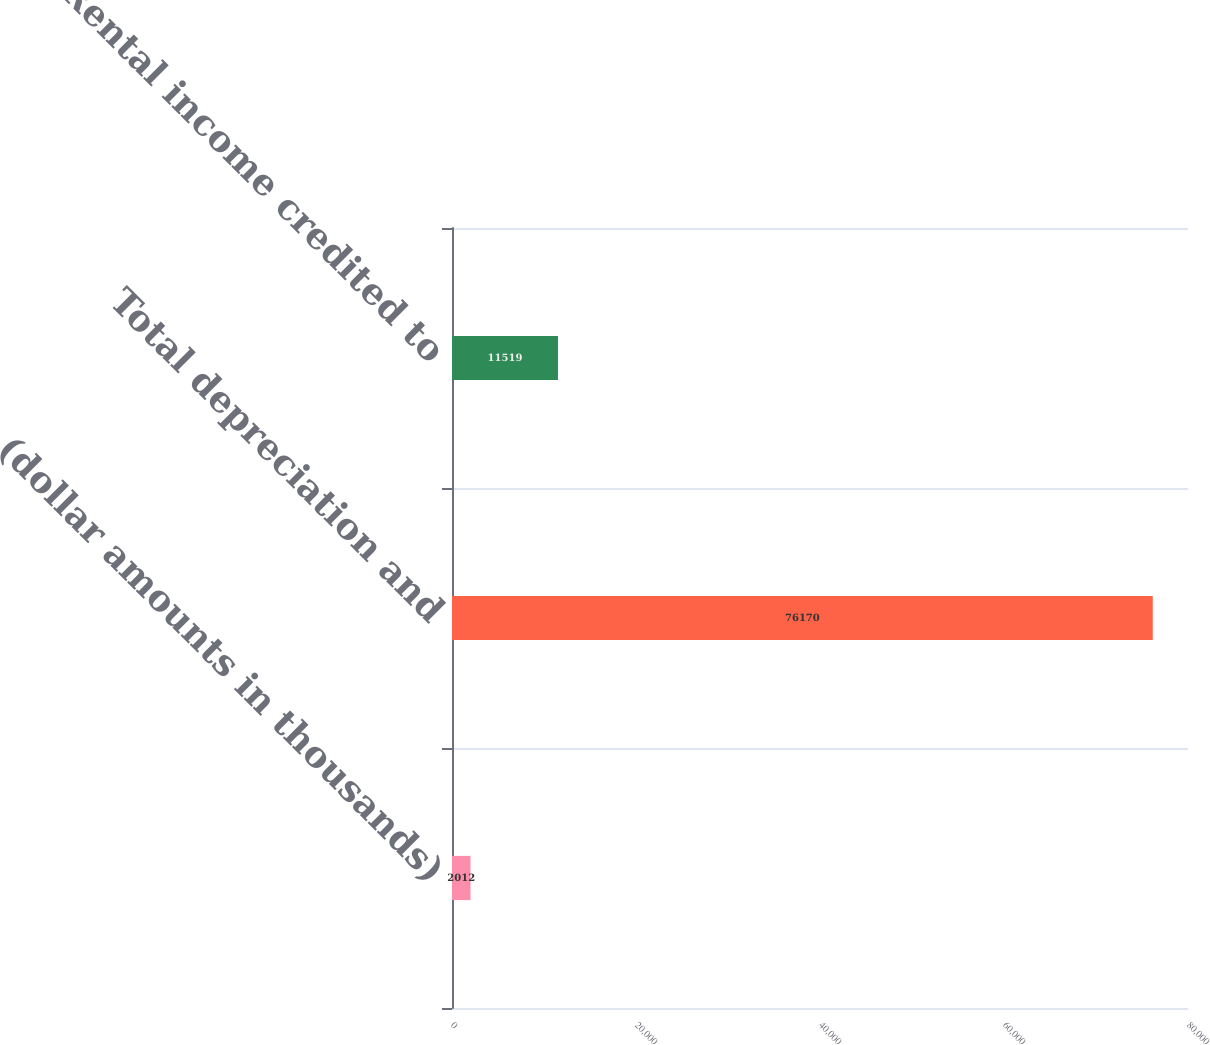Convert chart to OTSL. <chart><loc_0><loc_0><loc_500><loc_500><bar_chart><fcel>(dollar amounts in thousands)<fcel>Total depreciation and<fcel>Rental income credited to<nl><fcel>2012<fcel>76170<fcel>11519<nl></chart> 